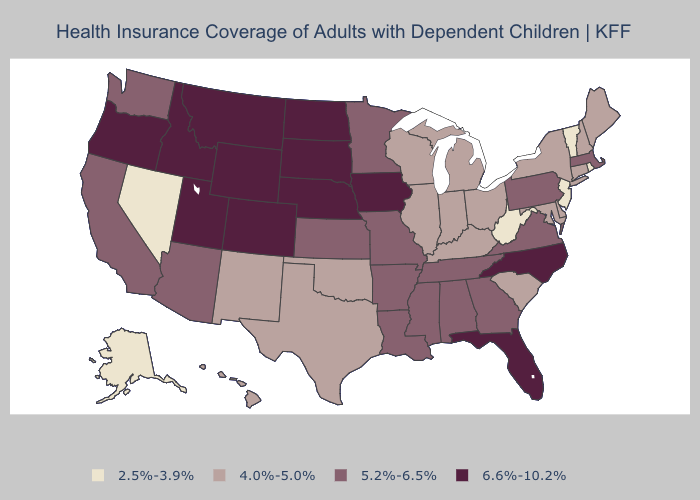What is the value of Wyoming?
Answer briefly. 6.6%-10.2%. Does Rhode Island have the lowest value in the USA?
Short answer required. Yes. Among the states that border Michigan , which have the highest value?
Be succinct. Indiana, Ohio, Wisconsin. What is the value of Minnesota?
Keep it brief. 5.2%-6.5%. What is the value of Montana?
Quick response, please. 6.6%-10.2%. Which states have the lowest value in the USA?
Quick response, please. Alaska, Nevada, New Jersey, Rhode Island, Vermont, West Virginia. Name the states that have a value in the range 2.5%-3.9%?
Answer briefly. Alaska, Nevada, New Jersey, Rhode Island, Vermont, West Virginia. Among the states that border Delaware , does Pennsylvania have the highest value?
Give a very brief answer. Yes. What is the value of Nebraska?
Concise answer only. 6.6%-10.2%. Which states have the highest value in the USA?
Write a very short answer. Colorado, Florida, Idaho, Iowa, Montana, Nebraska, North Carolina, North Dakota, Oregon, South Dakota, Utah, Wyoming. Does Rhode Island have the lowest value in the Northeast?
Short answer required. Yes. Which states have the lowest value in the USA?
Short answer required. Alaska, Nevada, New Jersey, Rhode Island, Vermont, West Virginia. Does Kansas have the highest value in the MidWest?
Quick response, please. No. Name the states that have a value in the range 4.0%-5.0%?
Give a very brief answer. Connecticut, Delaware, Hawaii, Illinois, Indiana, Kentucky, Maine, Maryland, Michigan, New Hampshire, New Mexico, New York, Ohio, Oklahoma, South Carolina, Texas, Wisconsin. 